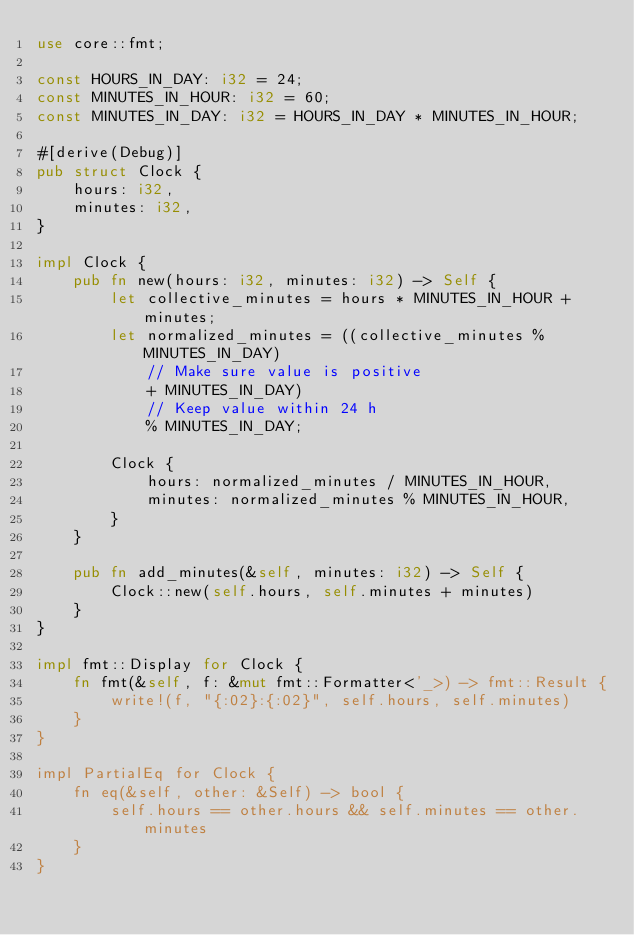<code> <loc_0><loc_0><loc_500><loc_500><_Rust_>use core::fmt;

const HOURS_IN_DAY: i32 = 24;
const MINUTES_IN_HOUR: i32 = 60;
const MINUTES_IN_DAY: i32 = HOURS_IN_DAY * MINUTES_IN_HOUR;

#[derive(Debug)]
pub struct Clock {
    hours: i32,
    minutes: i32,
}

impl Clock {
    pub fn new(hours: i32, minutes: i32) -> Self {
        let collective_minutes = hours * MINUTES_IN_HOUR + minutes;
        let normalized_minutes = ((collective_minutes % MINUTES_IN_DAY)
            // Make sure value is positive
            + MINUTES_IN_DAY)
            // Keep value within 24 h
            % MINUTES_IN_DAY;

        Clock {
            hours: normalized_minutes / MINUTES_IN_HOUR,
            minutes: normalized_minutes % MINUTES_IN_HOUR,
        }
    }

    pub fn add_minutes(&self, minutes: i32) -> Self {
        Clock::new(self.hours, self.minutes + minutes)
    }
}

impl fmt::Display for Clock {
    fn fmt(&self, f: &mut fmt::Formatter<'_>) -> fmt::Result {
        write!(f, "{:02}:{:02}", self.hours, self.minutes)
    }
}

impl PartialEq for Clock {
    fn eq(&self, other: &Self) -> bool {
        self.hours == other.hours && self.minutes == other.minutes
    }
}
</code> 